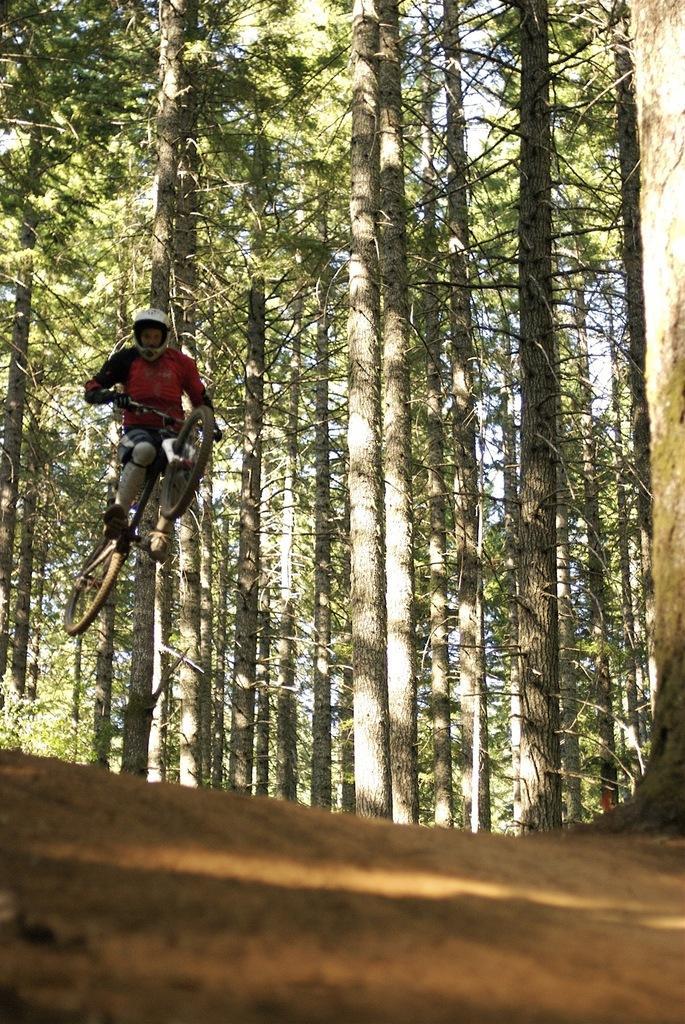In one or two sentences, can you explain what this image depicts? In the image there is a person jumping along with bicycle in the air and behind him there are trees all over the land. 